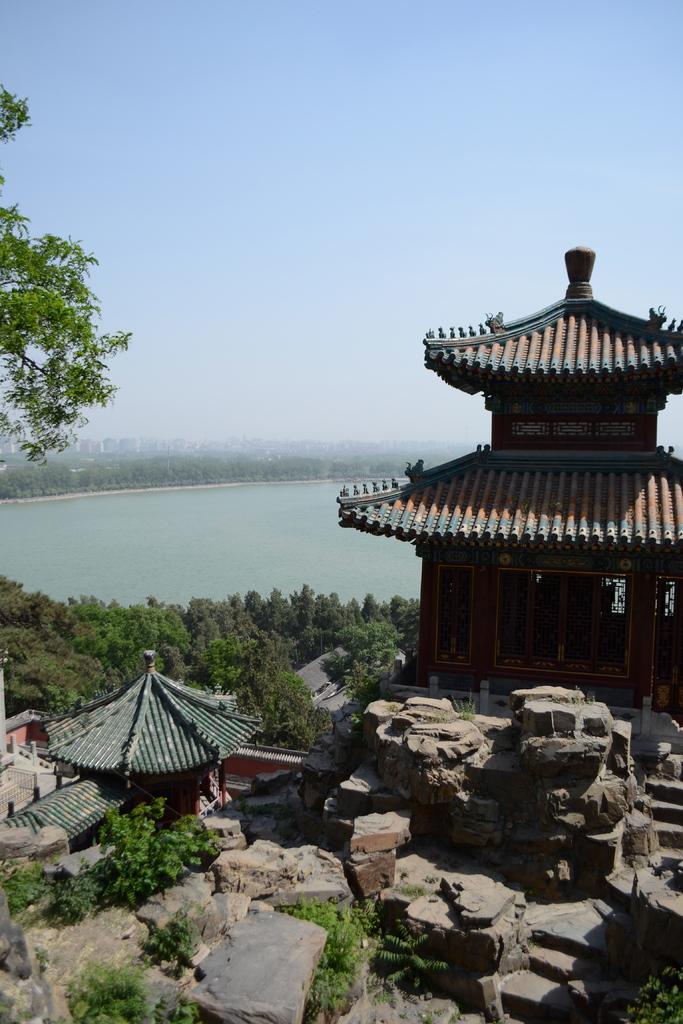Could you give a brief overview of what you see in this image? In this image we can see the buildings, there are some rocks, trees, and water, in the background, we can see the sky. 